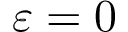<formula> <loc_0><loc_0><loc_500><loc_500>\varepsilon = 0</formula> 